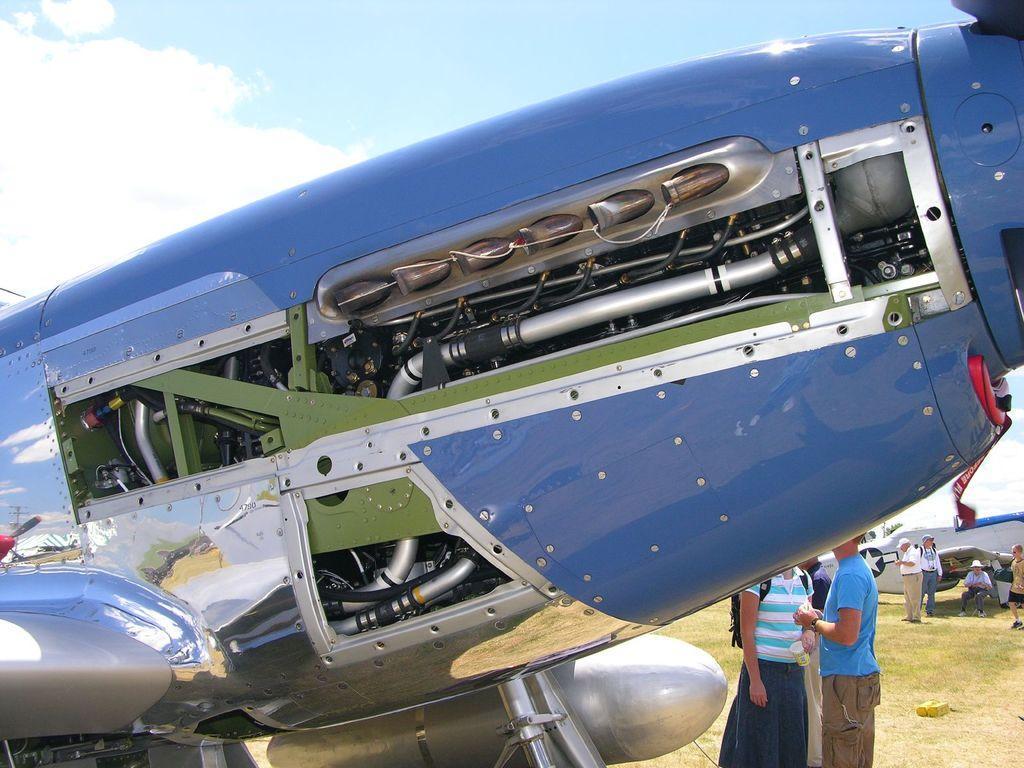Can you describe this image briefly? In this picture we can see airplanes, some people on the ground, some objects and in the background we can see the sky. 